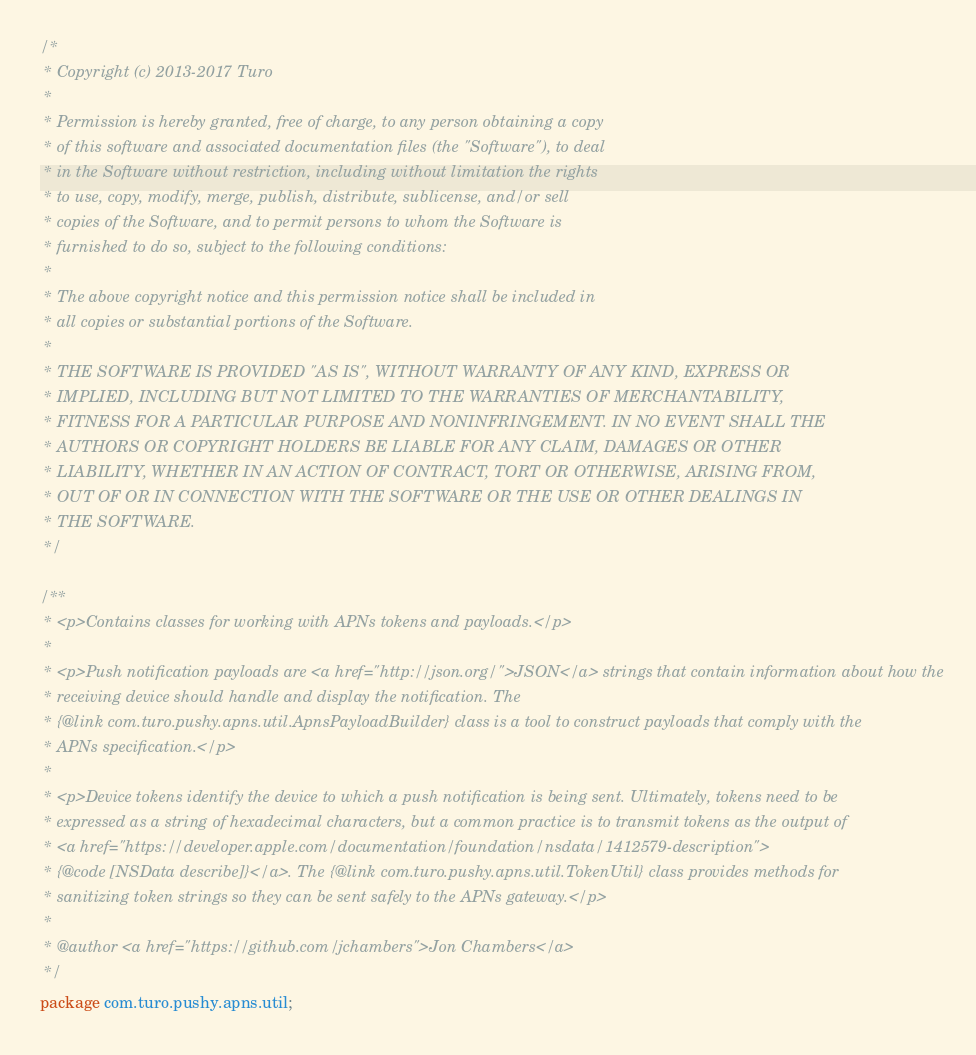<code> <loc_0><loc_0><loc_500><loc_500><_Java_>/*
 * Copyright (c) 2013-2017 Turo
 *
 * Permission is hereby granted, free of charge, to any person obtaining a copy
 * of this software and associated documentation files (the "Software"), to deal
 * in the Software without restriction, including without limitation the rights
 * to use, copy, modify, merge, publish, distribute, sublicense, and/or sell
 * copies of the Software, and to permit persons to whom the Software is
 * furnished to do so, subject to the following conditions:
 *
 * The above copyright notice and this permission notice shall be included in
 * all copies or substantial portions of the Software.
 *
 * THE SOFTWARE IS PROVIDED "AS IS", WITHOUT WARRANTY OF ANY KIND, EXPRESS OR
 * IMPLIED, INCLUDING BUT NOT LIMITED TO THE WARRANTIES OF MERCHANTABILITY,
 * FITNESS FOR A PARTICULAR PURPOSE AND NONINFRINGEMENT. IN NO EVENT SHALL THE
 * AUTHORS OR COPYRIGHT HOLDERS BE LIABLE FOR ANY CLAIM, DAMAGES OR OTHER
 * LIABILITY, WHETHER IN AN ACTION OF CONTRACT, TORT OR OTHERWISE, ARISING FROM,
 * OUT OF OR IN CONNECTION WITH THE SOFTWARE OR THE USE OR OTHER DEALINGS IN
 * THE SOFTWARE.
 */

/**
 * <p>Contains classes for working with APNs tokens and payloads.</p>
 *
 * <p>Push notification payloads are <a href="http://json.org/">JSON</a> strings that contain information about how the
 * receiving device should handle and display the notification. The
 * {@link com.turo.pushy.apns.util.ApnsPayloadBuilder} class is a tool to construct payloads that comply with the
 * APNs specification.</p>
 *
 * <p>Device tokens identify the device to which a push notification is being sent. Ultimately, tokens need to be
 * expressed as a string of hexadecimal characters, but a common practice is to transmit tokens as the output of
 * <a href="https://developer.apple.com/documentation/foundation/nsdata/1412579-description">
 * {@code [NSData describe]}</a>. The {@link com.turo.pushy.apns.util.TokenUtil} class provides methods for
 * sanitizing token strings so they can be sent safely to the APNs gateway.</p>
 *
 * @author <a href="https://github.com/jchambers">Jon Chambers</a>
 */
package com.turo.pushy.apns.util;
</code> 